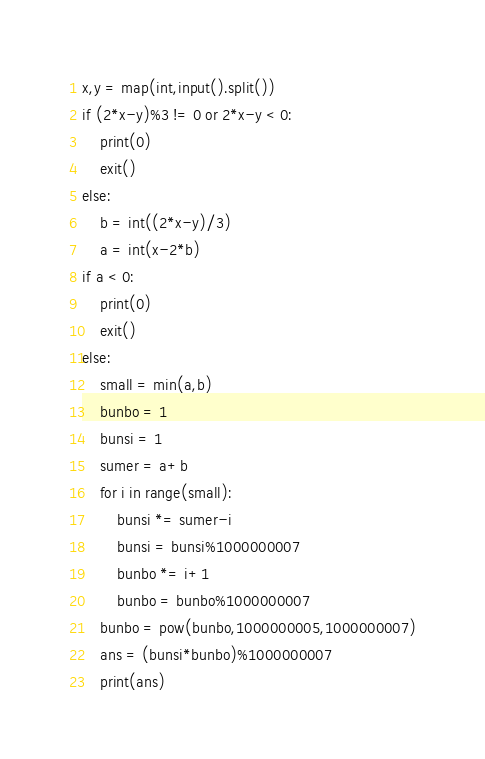<code> <loc_0><loc_0><loc_500><loc_500><_Python_>x,y = map(int,input().split())
if (2*x-y)%3 != 0 or 2*x-y < 0:
    print(0)
    exit()
else:
    b = int((2*x-y)/3)
    a = int(x-2*b)
if a < 0:
    print(0)
    exit()
else:
    small = min(a,b)
    bunbo = 1
    bunsi = 1
    sumer = a+b
    for i in range(small):
        bunsi *= sumer-i
        bunsi = bunsi%1000000007
        bunbo *= i+1
        bunbo = bunbo%1000000007
    bunbo = pow(bunbo,1000000005,1000000007)
    ans = (bunsi*bunbo)%1000000007
    print(ans)</code> 